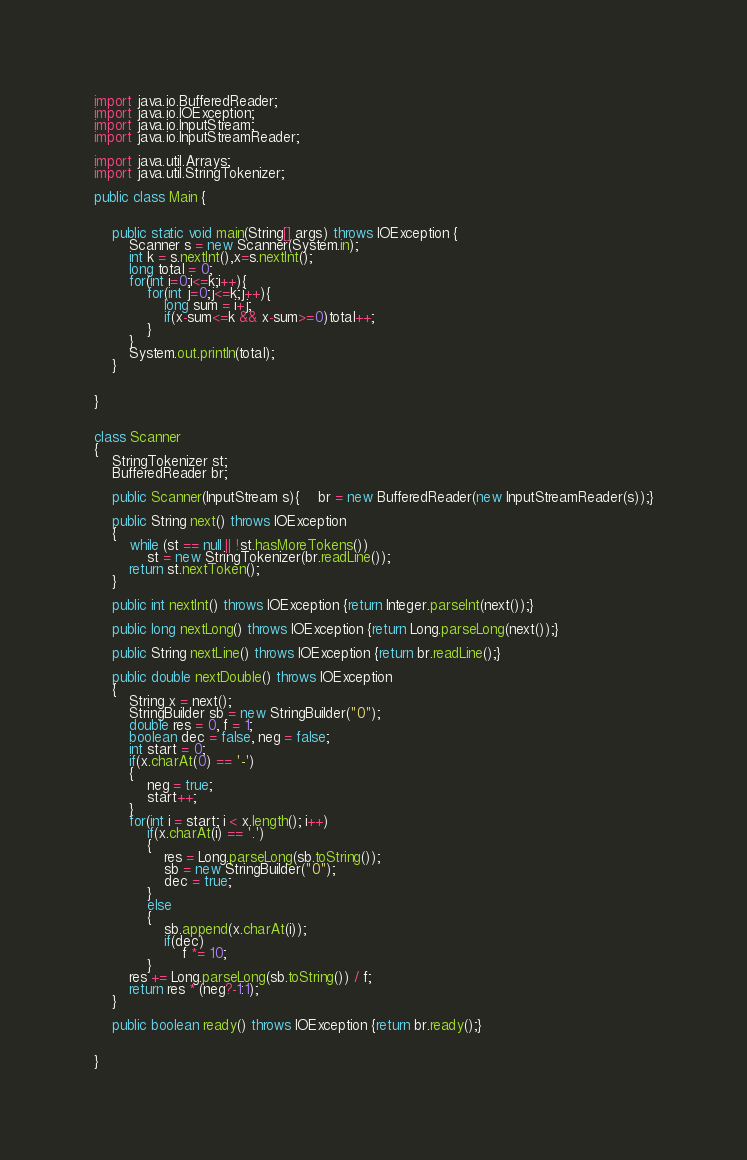Convert code to text. <code><loc_0><loc_0><loc_500><loc_500><_Java_>
import java.io.BufferedReader;
import java.io.IOException;
import java.io.InputStream;
import java.io.InputStreamReader;

import java.util.Arrays;
import java.util.StringTokenizer;

public class Main {


    public static void main(String[] args) throws IOException {
        Scanner s = new Scanner(System.in);
        int k = s.nextInt(),x=s.nextInt();
        long total = 0;
        for(int i=0;i<=k;i++){
            for(int j=0;j<=k;j++){
                long sum = i+j;
                if(x-sum<=k && x-sum>=0)total++;
            }
        }
        System.out.println(total);
    }


}


class Scanner
{
    StringTokenizer st;
    BufferedReader br;

    public Scanner(InputStream s){	br = new BufferedReader(new InputStreamReader(s));}

    public String next() throws IOException
    {
        while (st == null || !st.hasMoreTokens())
            st = new StringTokenizer(br.readLine());
        return st.nextToken();
    }

    public int nextInt() throws IOException {return Integer.parseInt(next());}

    public long nextLong() throws IOException {return Long.parseLong(next());}

    public String nextLine() throws IOException {return br.readLine();}

    public double nextDouble() throws IOException
    {
        String x = next();
        StringBuilder sb = new StringBuilder("0");
        double res = 0, f = 1;
        boolean dec = false, neg = false;
        int start = 0;
        if(x.charAt(0) == '-')
        {
            neg = true;
            start++;
        }
        for(int i = start; i < x.length(); i++)
            if(x.charAt(i) == '.')
            {
                res = Long.parseLong(sb.toString());
                sb = new StringBuilder("0");
                dec = true;
            }
            else
            {
                sb.append(x.charAt(i));
                if(dec)
                    f *= 10;
            }
        res += Long.parseLong(sb.toString()) / f;
        return res * (neg?-1:1);
    }

    public boolean ready() throws IOException {return br.ready();}


}</code> 